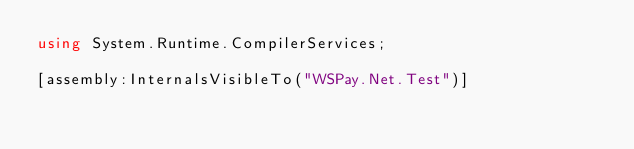Convert code to text. <code><loc_0><loc_0><loc_500><loc_500><_C#_>using System.Runtime.CompilerServices;

[assembly:InternalsVisibleTo("WSPay.Net.Test")]</code> 